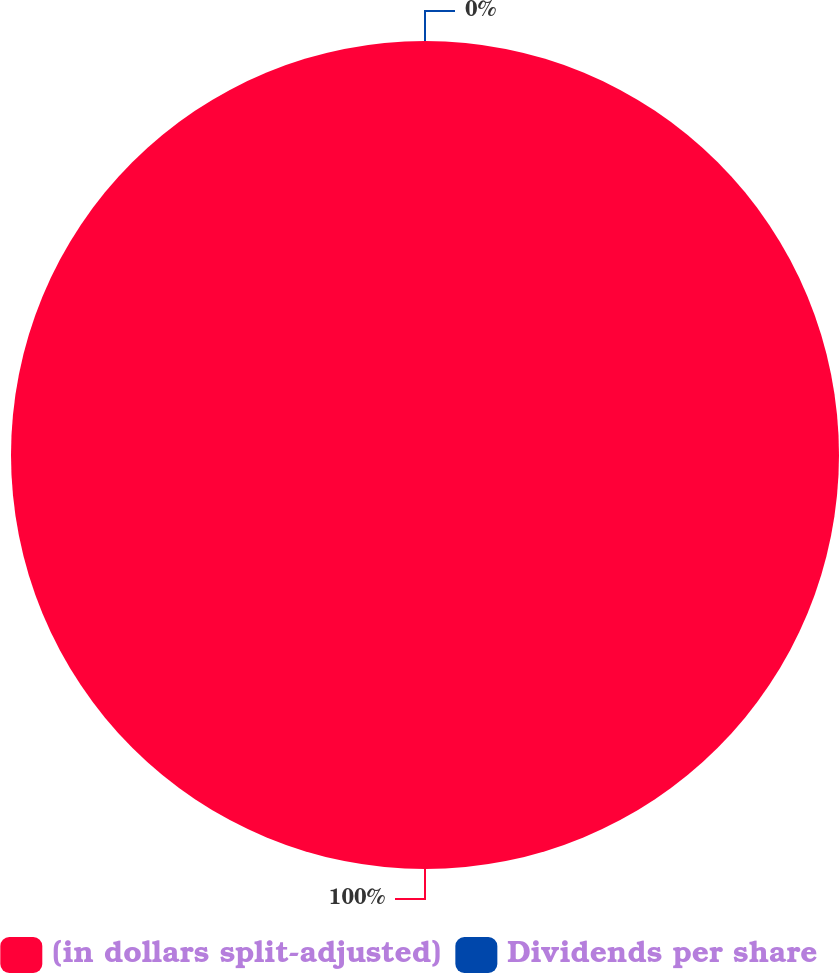<chart> <loc_0><loc_0><loc_500><loc_500><pie_chart><fcel>(in dollars split-adjusted)<fcel>Dividends per share<nl><fcel>100.0%<fcel>0.0%<nl></chart> 